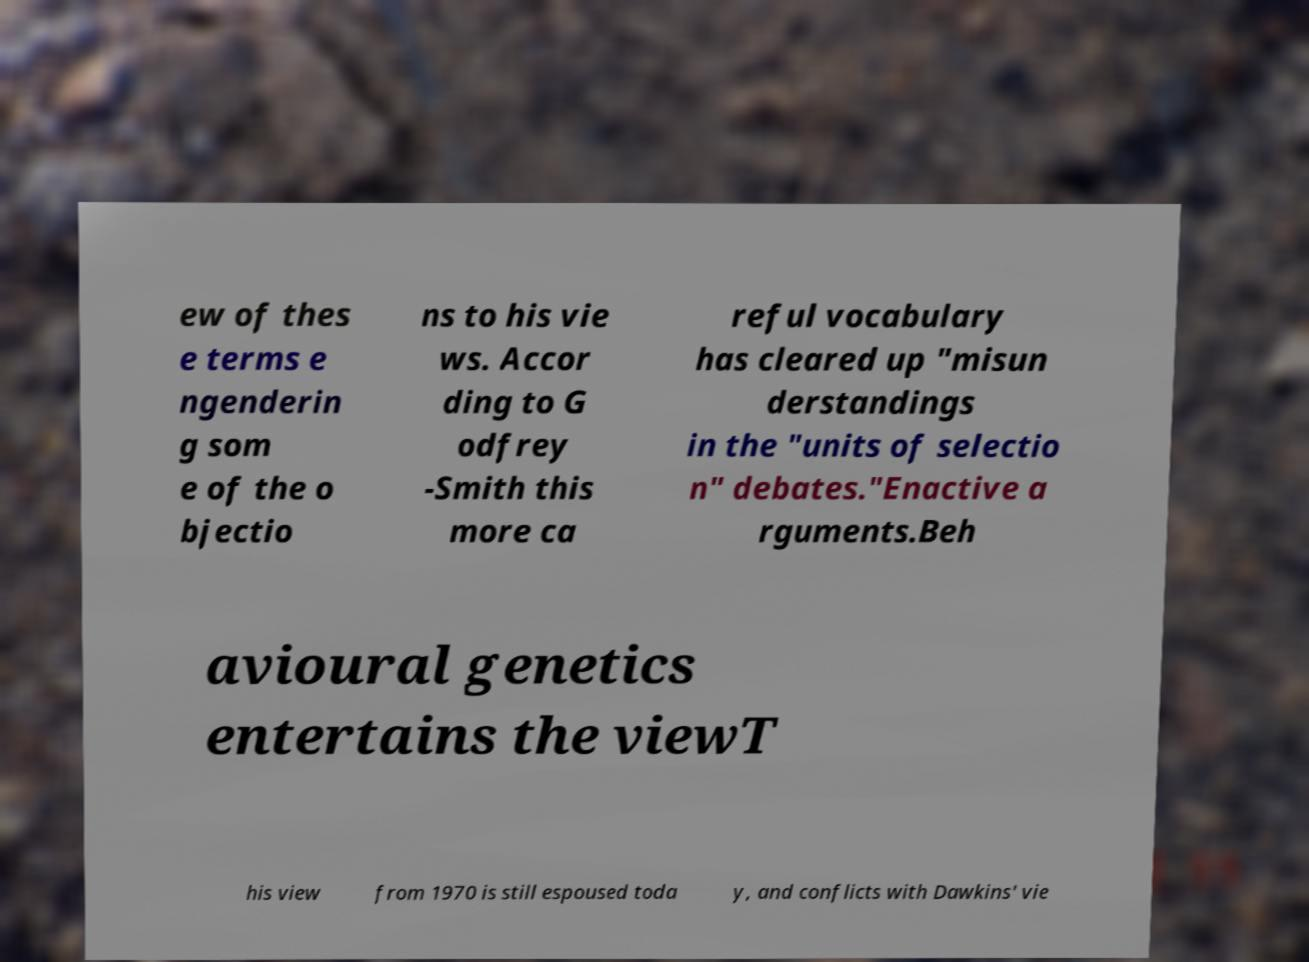What messages or text are displayed in this image? I need them in a readable, typed format. ew of thes e terms e ngenderin g som e of the o bjectio ns to his vie ws. Accor ding to G odfrey -Smith this more ca reful vocabulary has cleared up "misun derstandings in the "units of selectio n" debates."Enactive a rguments.Beh avioural genetics entertains the viewT his view from 1970 is still espoused toda y, and conflicts with Dawkins' vie 